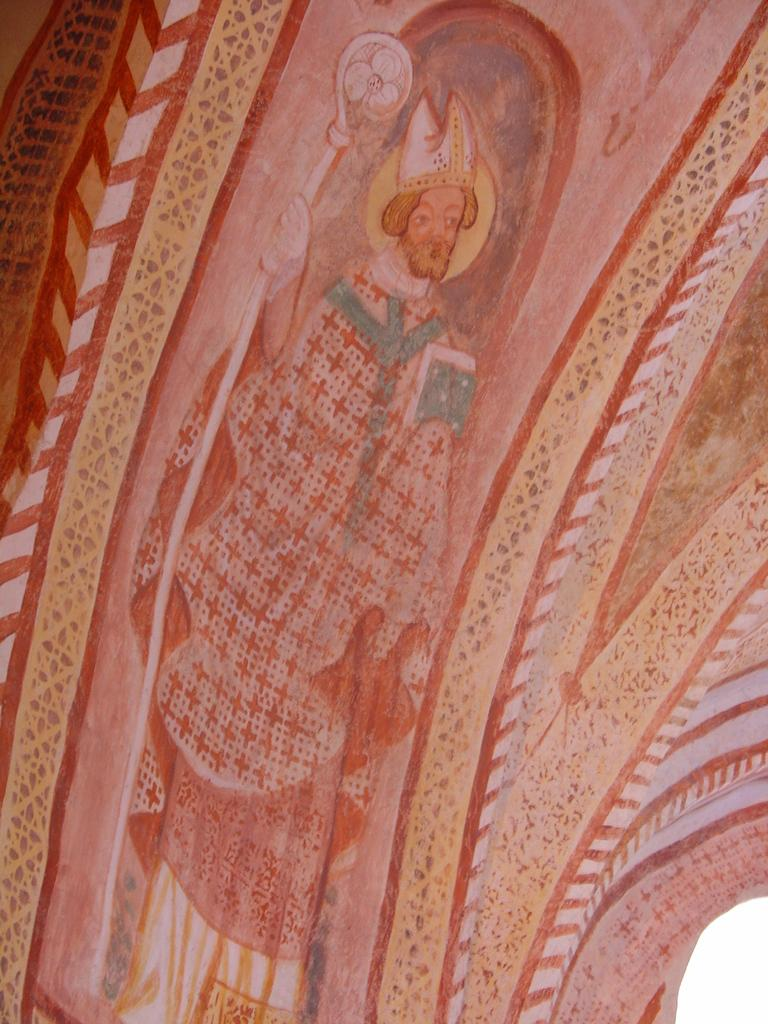What is the main subject of the image? There is a painting in the image. What does the painting depict? The painting depicts a person. What else can be observed in the painting? The painting includes a design. What type of arch can be seen in the painting? There is no arch present in the painting; it depicts a person and includes a design. How much was the payment for the painting? There is no information about the payment for the painting in the image or the provided facts. 